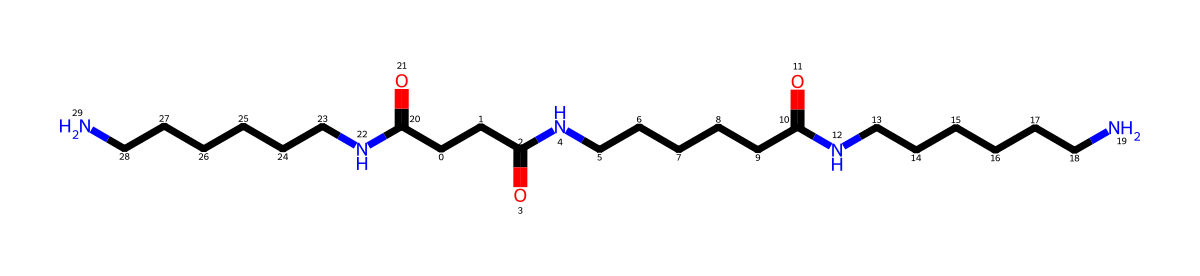how many carbon atoms are in this polymer? By analyzing the SMILES representation, we can count the number of carbon (C) atoms present. Each 'C' in the SMILES indicates a carbon atom. In the given structure, there are 18 instances of 'C', hence there are 18 carbon atoms.
Answer: 18 what type of polymer is represented here? The presence of amide linkages (C(=O)N) in the structure indicates that this polymer is a polyamide. Polyamides are characterized by the repetitive amide group in their structures, which is evident here.
Answer: polyamide how many amide groups are present? The presence of the amide functional group (C(=O)N) in the SMILES can be counted. There are three occurrences of the amide group within the structure, as evidenced by the three instances of 'N' following a carbon carbonyl (C=O).
Answer: 3 is this polymer likely to be hydrophilic or hydrophobic? The presence of multiple amide groups (which can form hydrogen bonds with water) suggests that this polymer is hydrophilic. The polar nature of these groups allows for interaction with water molecules, making it more likely to be hydrophilic in nature.
Answer: hydrophilic what is the molecular formula of this polymer? To derive the molecular formula, we can determine the number of each type of atom in the SMILES. Counting gives us C18, H36, N6, and O3, which together form the molecular formula C18H36N6O3.
Answer: C18H36N6O3 what does the presence of nitrogen atoms imply about the polymer’s properties? The presence of nitrogen atoms typically implies that the polymer may have higher tensile strength and thermal stability compared to non-nitrogen containing polymers. This is due to the properties of amide linkages that exist within the polymer chain.
Answer: higher strength 